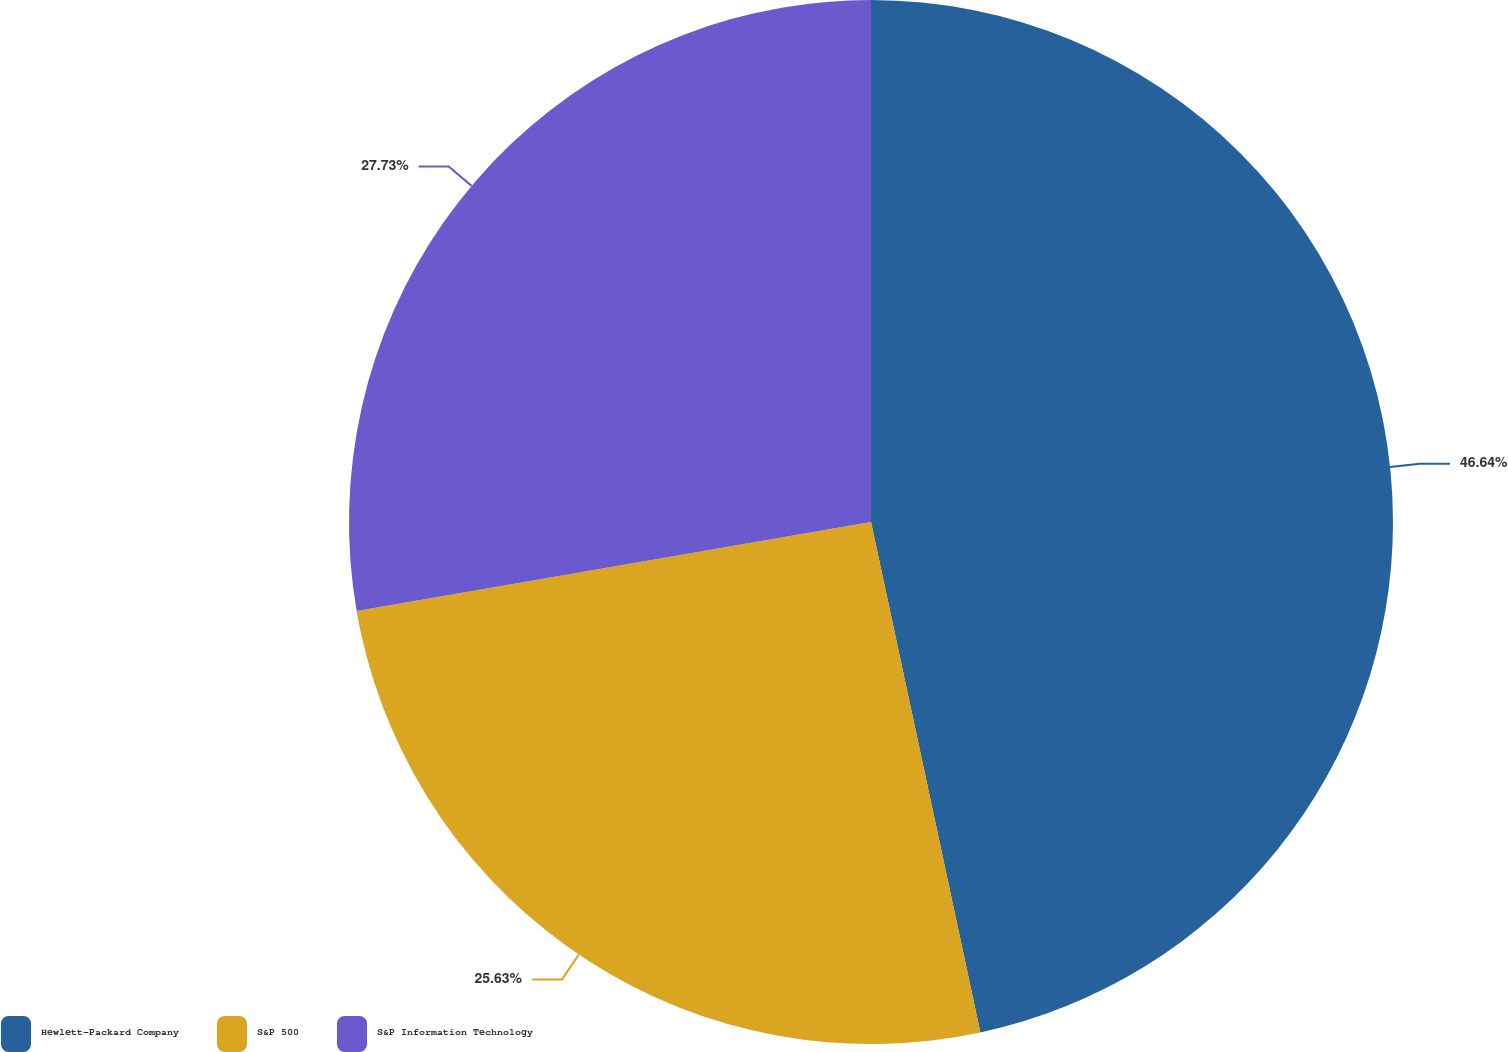Convert chart. <chart><loc_0><loc_0><loc_500><loc_500><pie_chart><fcel>Hewlett-Packard Company<fcel>S&P 500<fcel>S&P Information Technology<nl><fcel>46.64%<fcel>25.63%<fcel>27.73%<nl></chart> 